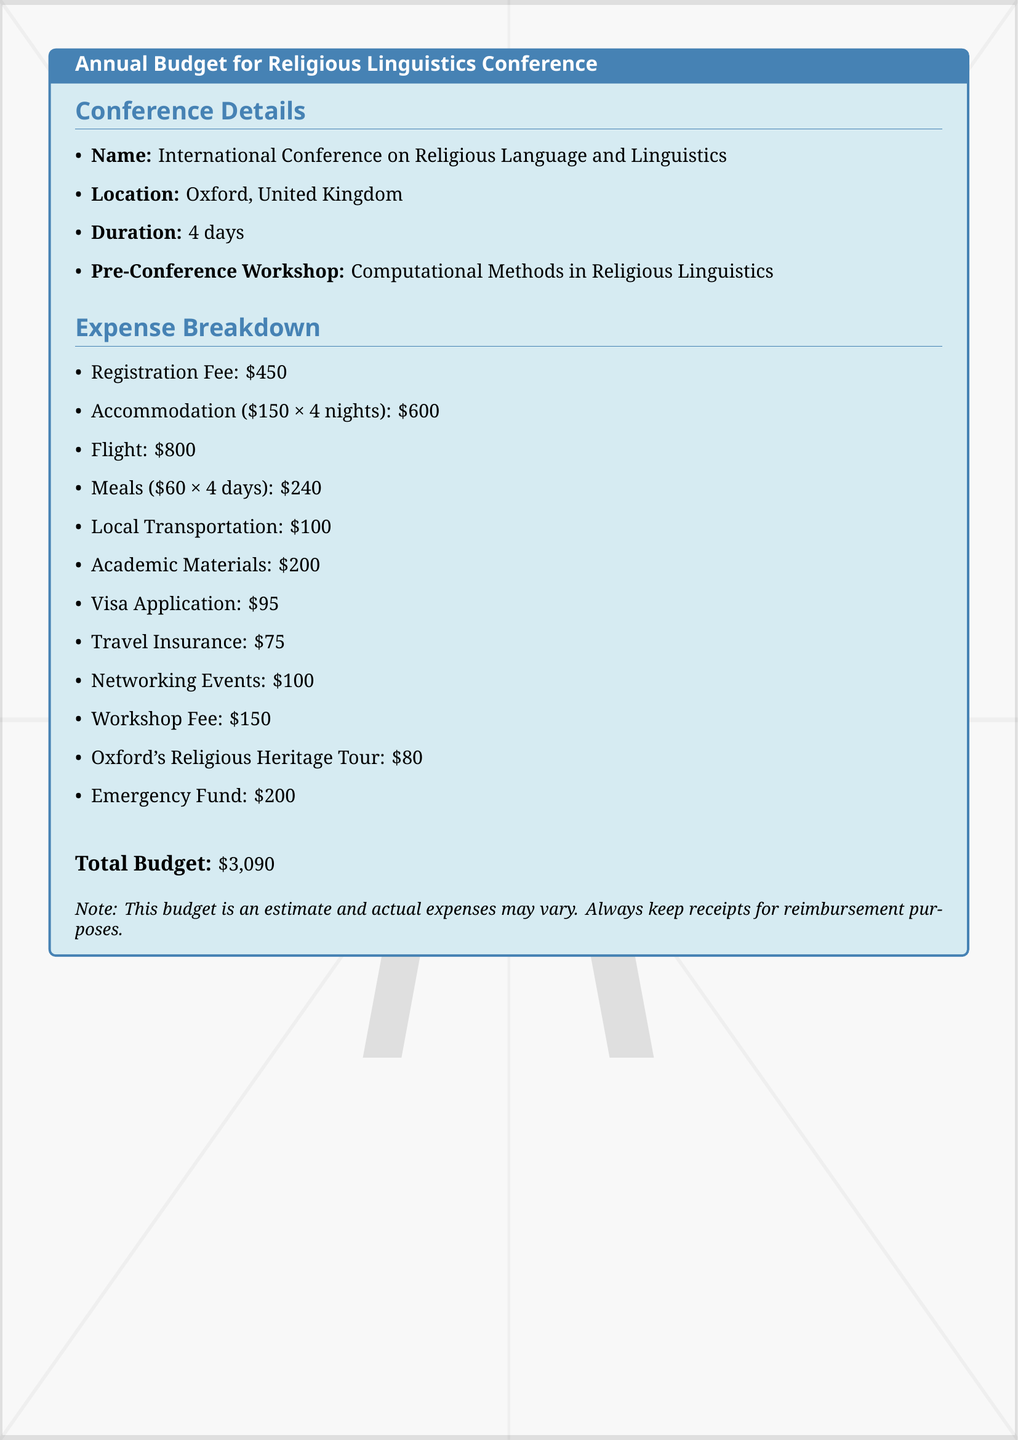What is the name of the conference? The document lists the conference name under the details section, which is "International Conference on Religious Language and Linguistics."
Answer: International Conference on Religious Language and Linguistics Where is the conference located? The location of the conference is specified in the conference details section.
Answer: Oxford, United Kingdom What is the duration of the conference? The duration is mentioned as "4 days" in the details section.
Answer: 4 days What is the total budget? The total budget is stated at the end of the expense breakdown section.
Answer: $3,090 How much is allocated for meals? The document specifies meal expenses as "$60 × 4 days" in the expense breakdown.
Answer: $240 What is the registration fee? The registration fee is listed as an individual item in the expense breakdown.
Answer: $450 How much is budgeted for the flight? The flight expense is clearly mentioned in the breakdown section of the document.
Answer: $800 What is the visa application fee? The document lists the visa application fee separately in the expense breakdown.
Answer: $95 What is the cost of the Oxford's Religious Heritage Tour? The cost for this tour is included in the expense breakdown section.
Answer: $80 